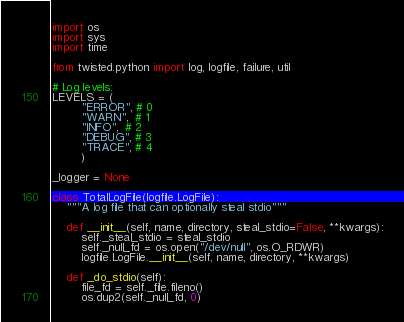<code> <loc_0><loc_0><loc_500><loc_500><_Python_>
import os
import sys
import time

from twisted.python import log, logfile, failure, util

# Log levels:
LEVELS = (
        "ERROR", # 0
        "WARN",  # 1
        "INFO",  # 2
        "DEBUG", # 3
        "TRACE", # 4
        )

_logger = None

class TotalLogFile(logfile.LogFile):
    """A log file that can optionally steal stdio"""

    def __init__(self, name, directory, steal_stdio=False, **kwargs):
        self._steal_stdio = steal_stdio
        self._null_fd = os.open("/dev/null", os.O_RDWR)
        logfile.LogFile.__init__(self, name, directory, **kwargs)

    def _do_stdio(self):
        file_fd = self._file.fileno()
        os.dup2(self._null_fd, 0)</code> 